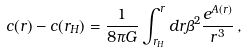Convert formula to latex. <formula><loc_0><loc_0><loc_500><loc_500>c ( r ) - c ( r _ { H } ) = \frac { 1 } { 8 \pi G } \int _ { r _ { H } } ^ { r } d r \beta ^ { 2 } \frac { e ^ { A ( r ) } } { r ^ { 3 } } \, ,</formula> 